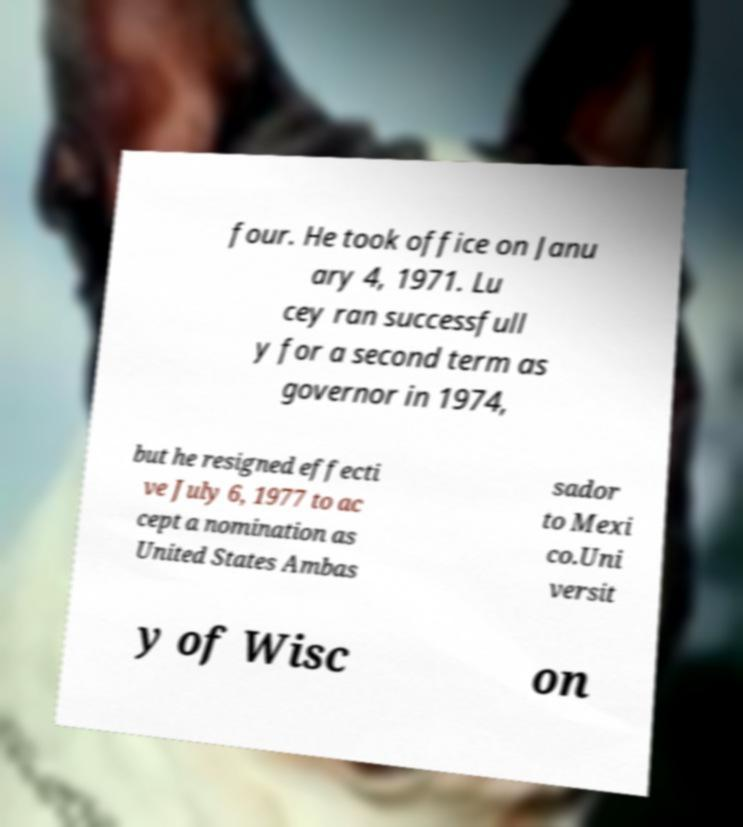Please identify and transcribe the text found in this image. four. He took office on Janu ary 4, 1971. Lu cey ran successfull y for a second term as governor in 1974, but he resigned effecti ve July 6, 1977 to ac cept a nomination as United States Ambas sador to Mexi co.Uni versit y of Wisc on 